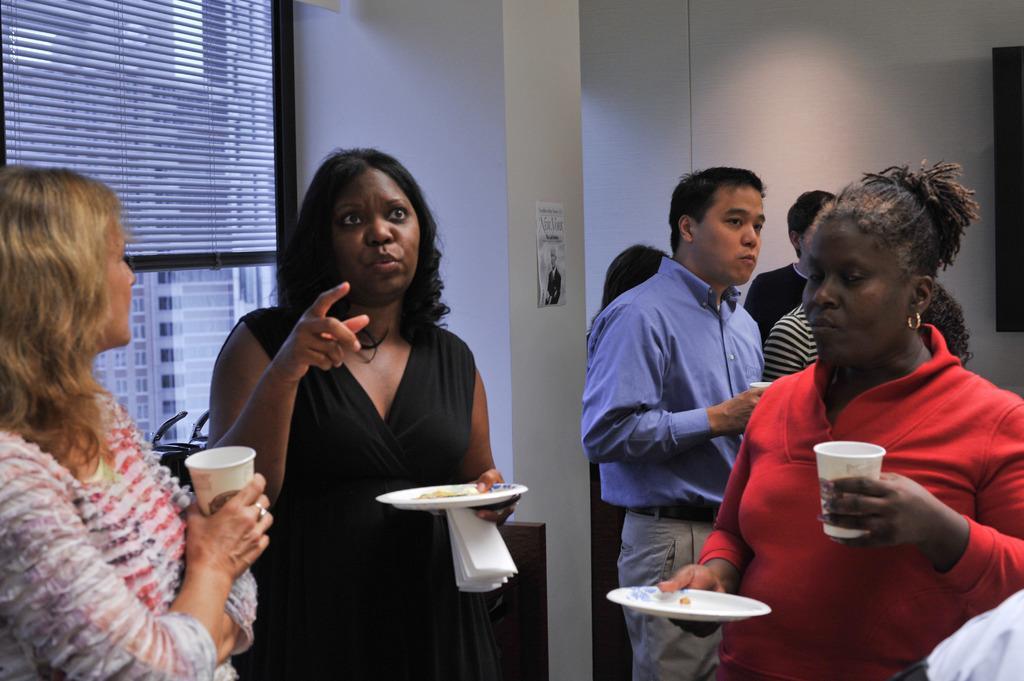Can you describe this image briefly? There are groups of people standing. This looks like a pillar. I can see a poster attached to the pillar. This is the window. I think this is the plastic roller blind. 